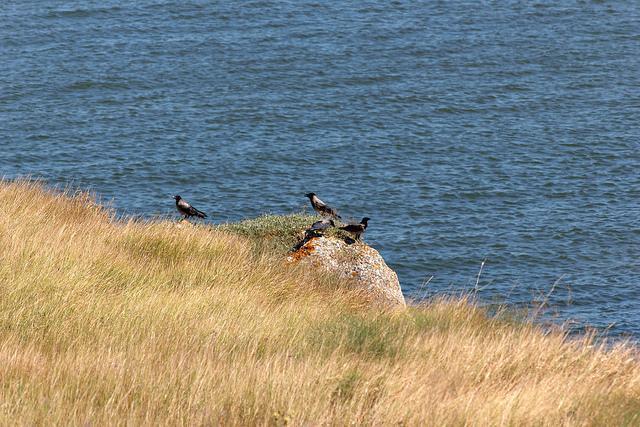How many birds can be spotted here?
Give a very brief answer. 4. How many people are not wearing goggles?
Give a very brief answer. 0. 